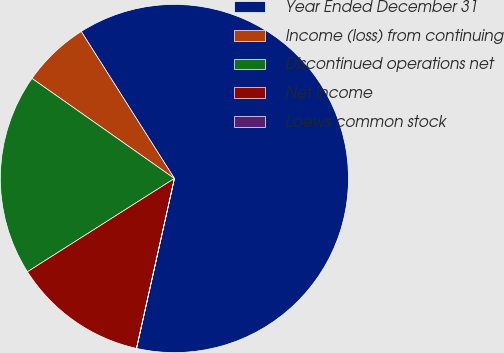Convert chart to OTSL. <chart><loc_0><loc_0><loc_500><loc_500><pie_chart><fcel>Year Ended December 31<fcel>Income (loss) from continuing<fcel>Discontinued operations net<fcel>Net income<fcel>Loews common stock<nl><fcel>62.48%<fcel>6.26%<fcel>18.75%<fcel>12.5%<fcel>0.01%<nl></chart> 